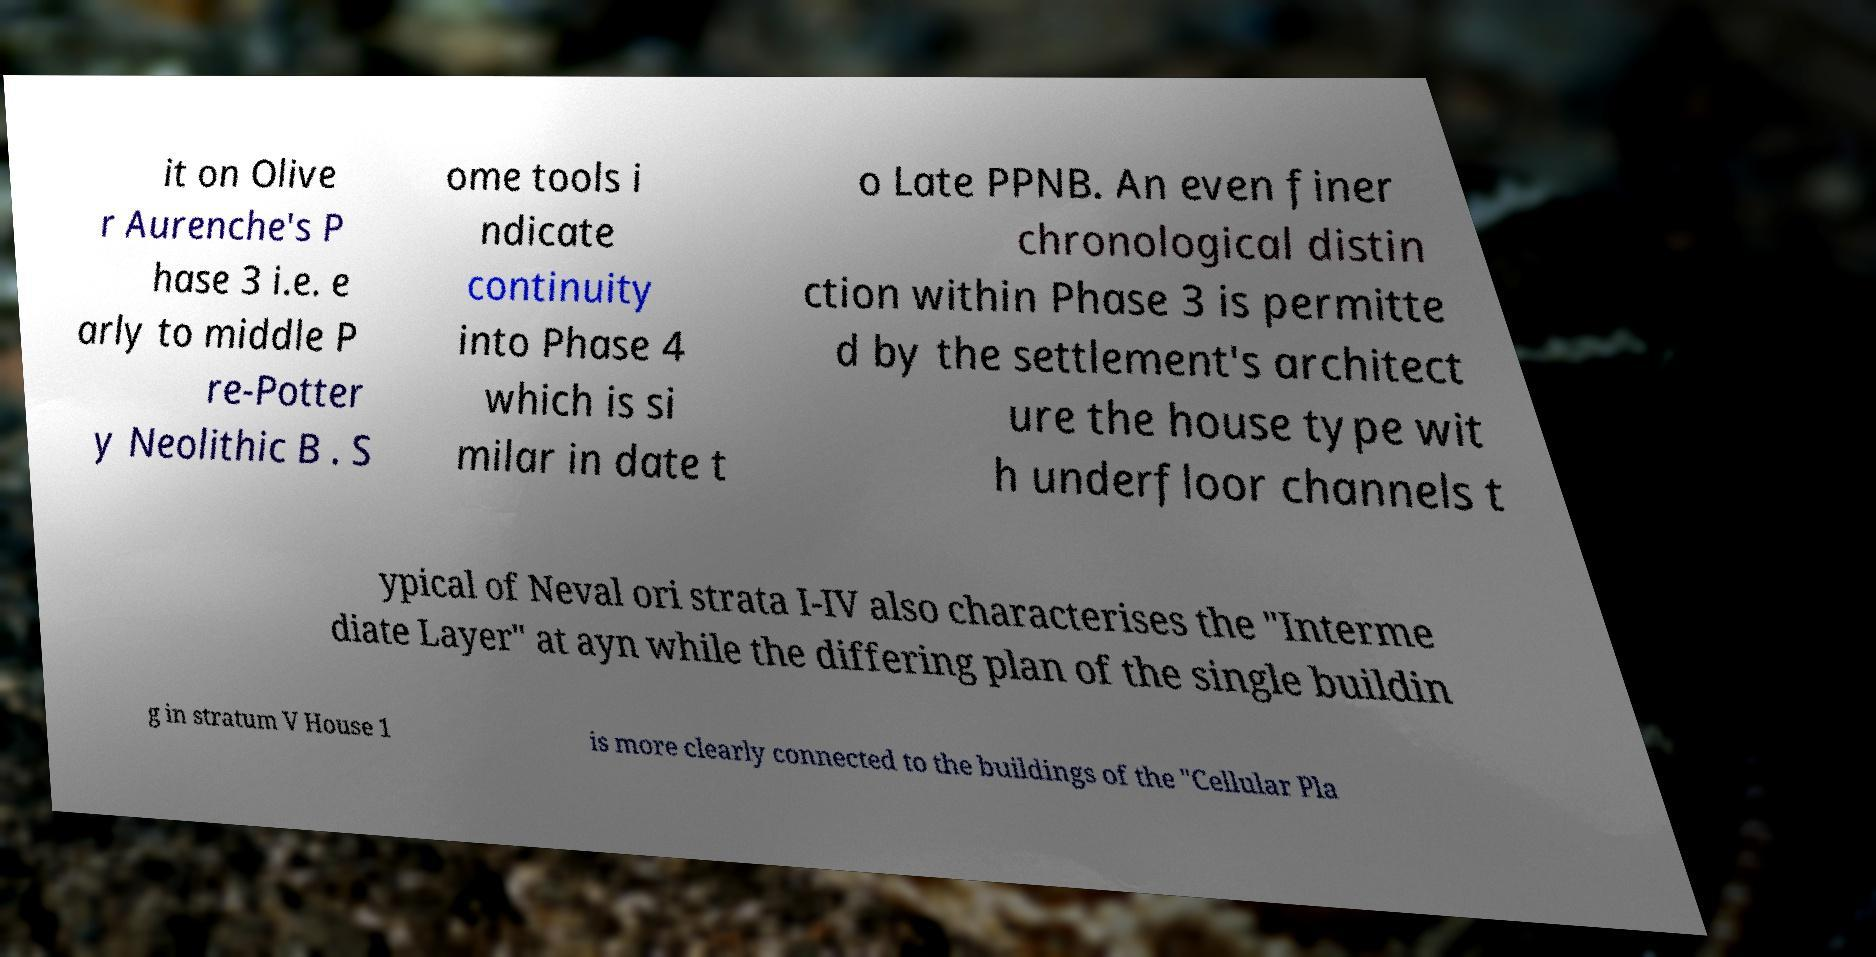Please read and relay the text visible in this image. What does it say? it on Olive r Aurenche's P hase 3 i.e. e arly to middle P re-Potter y Neolithic B . S ome tools i ndicate continuity into Phase 4 which is si milar in date t o Late PPNB. An even finer chronological distin ction within Phase 3 is permitte d by the settlement's architect ure the house type wit h underfloor channels t ypical of Neval ori strata I-IV also characterises the "Interme diate Layer" at ayn while the differing plan of the single buildin g in stratum V House 1 is more clearly connected to the buildings of the "Cellular Pla 